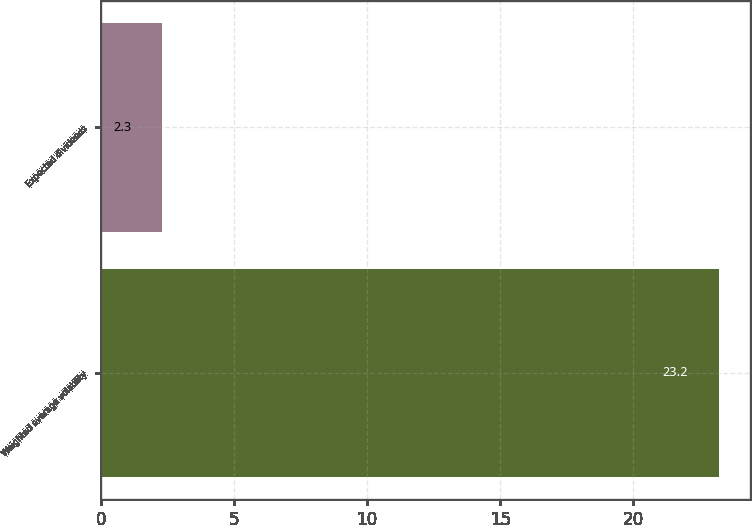<chart> <loc_0><loc_0><loc_500><loc_500><bar_chart><fcel>Weighted average volatility<fcel>Expected dividends<nl><fcel>23.2<fcel>2.3<nl></chart> 